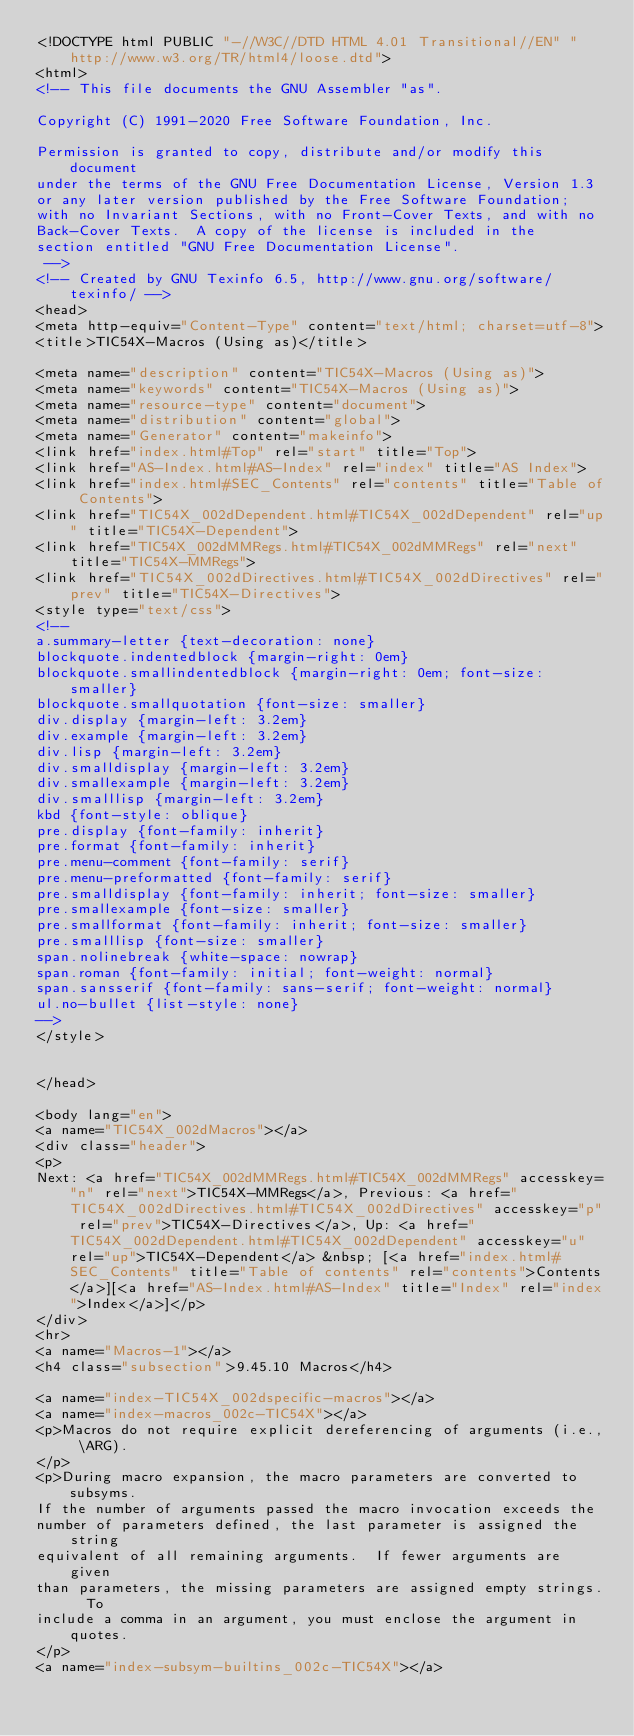Convert code to text. <code><loc_0><loc_0><loc_500><loc_500><_HTML_><!DOCTYPE html PUBLIC "-//W3C//DTD HTML 4.01 Transitional//EN" "http://www.w3.org/TR/html4/loose.dtd">
<html>
<!-- This file documents the GNU Assembler "as".

Copyright (C) 1991-2020 Free Software Foundation, Inc.

Permission is granted to copy, distribute and/or modify this document
under the terms of the GNU Free Documentation License, Version 1.3
or any later version published by the Free Software Foundation;
with no Invariant Sections, with no Front-Cover Texts, and with no
Back-Cover Texts.  A copy of the license is included in the
section entitled "GNU Free Documentation License".
 -->
<!-- Created by GNU Texinfo 6.5, http://www.gnu.org/software/texinfo/ -->
<head>
<meta http-equiv="Content-Type" content="text/html; charset=utf-8">
<title>TIC54X-Macros (Using as)</title>

<meta name="description" content="TIC54X-Macros (Using as)">
<meta name="keywords" content="TIC54X-Macros (Using as)">
<meta name="resource-type" content="document">
<meta name="distribution" content="global">
<meta name="Generator" content="makeinfo">
<link href="index.html#Top" rel="start" title="Top">
<link href="AS-Index.html#AS-Index" rel="index" title="AS Index">
<link href="index.html#SEC_Contents" rel="contents" title="Table of Contents">
<link href="TIC54X_002dDependent.html#TIC54X_002dDependent" rel="up" title="TIC54X-Dependent">
<link href="TIC54X_002dMMRegs.html#TIC54X_002dMMRegs" rel="next" title="TIC54X-MMRegs">
<link href="TIC54X_002dDirectives.html#TIC54X_002dDirectives" rel="prev" title="TIC54X-Directives">
<style type="text/css">
<!--
a.summary-letter {text-decoration: none}
blockquote.indentedblock {margin-right: 0em}
blockquote.smallindentedblock {margin-right: 0em; font-size: smaller}
blockquote.smallquotation {font-size: smaller}
div.display {margin-left: 3.2em}
div.example {margin-left: 3.2em}
div.lisp {margin-left: 3.2em}
div.smalldisplay {margin-left: 3.2em}
div.smallexample {margin-left: 3.2em}
div.smalllisp {margin-left: 3.2em}
kbd {font-style: oblique}
pre.display {font-family: inherit}
pre.format {font-family: inherit}
pre.menu-comment {font-family: serif}
pre.menu-preformatted {font-family: serif}
pre.smalldisplay {font-family: inherit; font-size: smaller}
pre.smallexample {font-size: smaller}
pre.smallformat {font-family: inherit; font-size: smaller}
pre.smalllisp {font-size: smaller}
span.nolinebreak {white-space: nowrap}
span.roman {font-family: initial; font-weight: normal}
span.sansserif {font-family: sans-serif; font-weight: normal}
ul.no-bullet {list-style: none}
-->
</style>


</head>

<body lang="en">
<a name="TIC54X_002dMacros"></a>
<div class="header">
<p>
Next: <a href="TIC54X_002dMMRegs.html#TIC54X_002dMMRegs" accesskey="n" rel="next">TIC54X-MMRegs</a>, Previous: <a href="TIC54X_002dDirectives.html#TIC54X_002dDirectives" accesskey="p" rel="prev">TIC54X-Directives</a>, Up: <a href="TIC54X_002dDependent.html#TIC54X_002dDependent" accesskey="u" rel="up">TIC54X-Dependent</a> &nbsp; [<a href="index.html#SEC_Contents" title="Table of contents" rel="contents">Contents</a>][<a href="AS-Index.html#AS-Index" title="Index" rel="index">Index</a>]</p>
</div>
<hr>
<a name="Macros-1"></a>
<h4 class="subsection">9.45.10 Macros</h4>

<a name="index-TIC54X_002dspecific-macros"></a>
<a name="index-macros_002c-TIC54X"></a>
<p>Macros do not require explicit dereferencing of arguments (i.e., \ARG).
</p>
<p>During macro expansion, the macro parameters are converted to subsyms.
If the number of arguments passed the macro invocation exceeds the
number of parameters defined, the last parameter is assigned the string
equivalent of all remaining arguments.  If fewer arguments are given
than parameters, the missing parameters are assigned empty strings.  To
include a comma in an argument, you must enclose the argument in quotes.
</p>
<a name="index-subsym-builtins_002c-TIC54X"></a></code> 